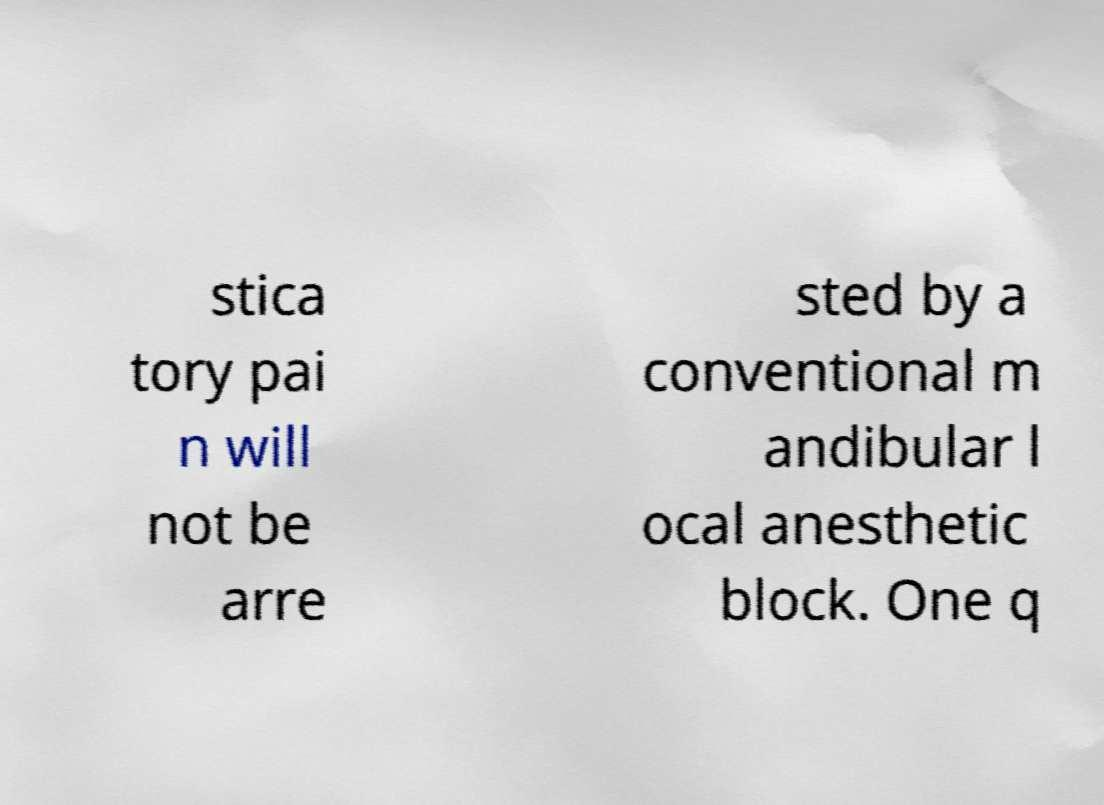Could you extract and type out the text from this image? stica tory pai n will not be arre sted by a conventional m andibular l ocal anesthetic block. One q 